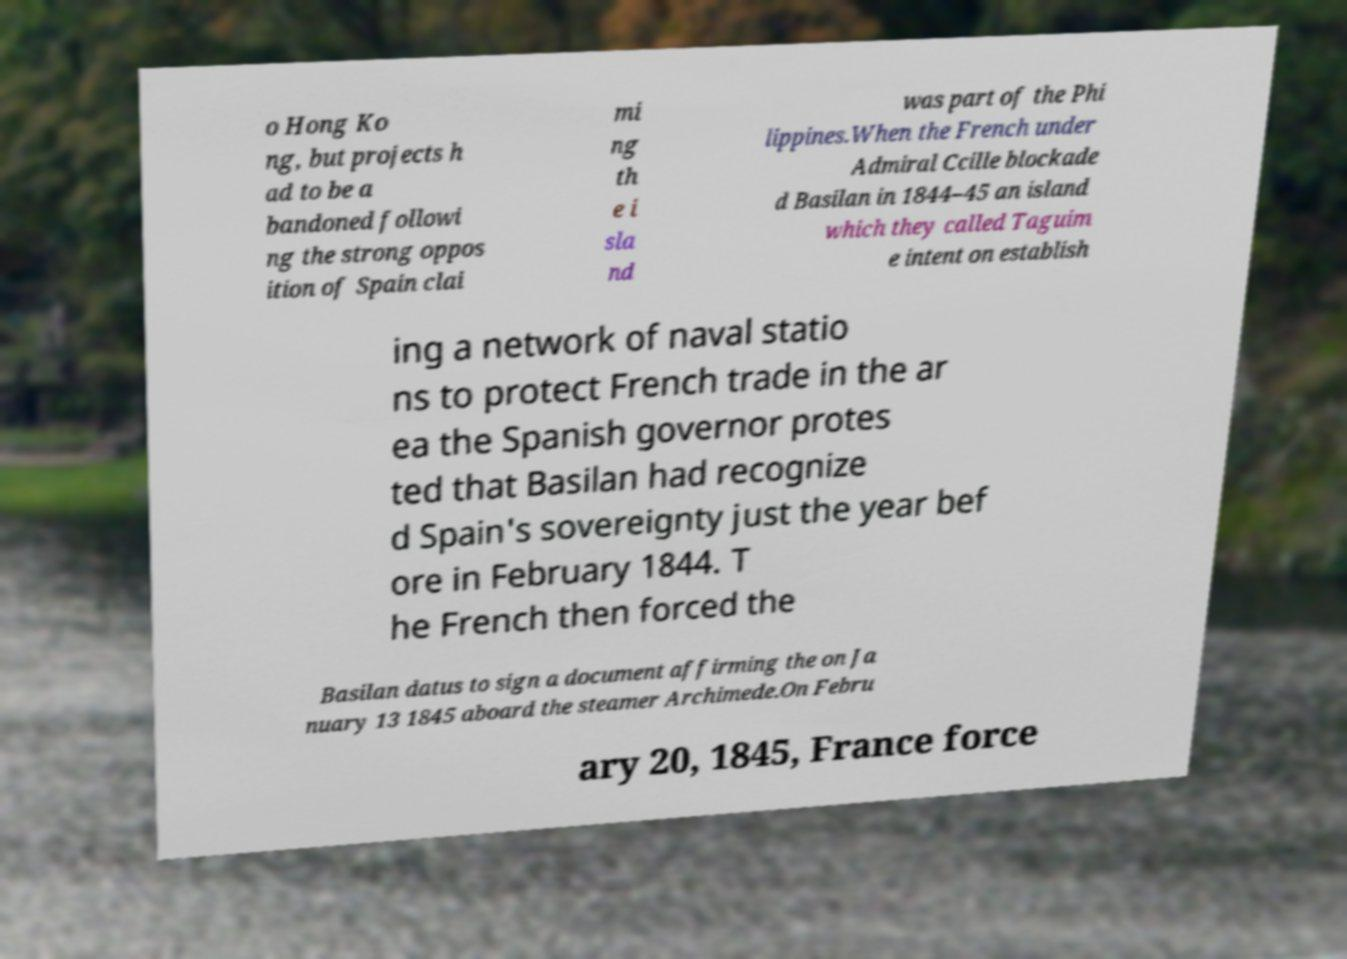Can you accurately transcribe the text from the provided image for me? o Hong Ko ng, but projects h ad to be a bandoned followi ng the strong oppos ition of Spain clai mi ng th e i sla nd was part of the Phi lippines.When the French under Admiral Ccille blockade d Basilan in 1844–45 an island which they called Taguim e intent on establish ing a network of naval statio ns to protect French trade in the ar ea the Spanish governor protes ted that Basilan had recognize d Spain's sovereignty just the year bef ore in February 1844. T he French then forced the Basilan datus to sign a document affirming the on Ja nuary 13 1845 aboard the steamer Archimede.On Febru ary 20, 1845, France force 